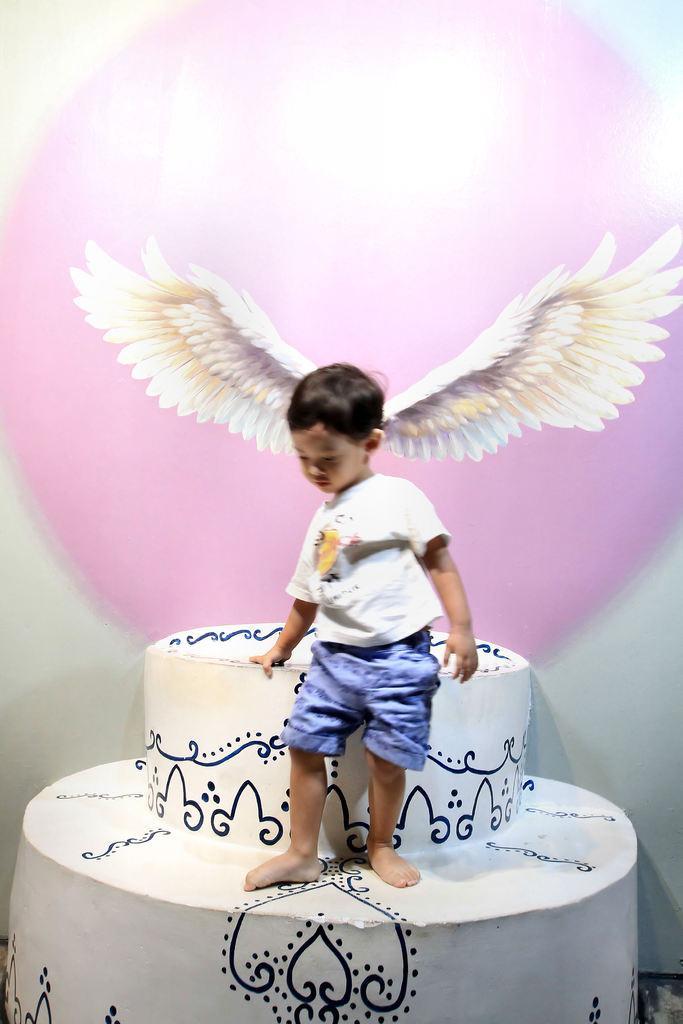Can you describe this image briefly? In this image there is an object, on that object a boy is standing, in the background there are wings. 